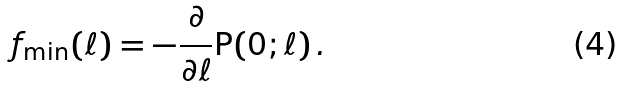<formula> <loc_0><loc_0><loc_500><loc_500>f _ { \min } ( \ell ) = - \frac { \partial } { \partial \ell } \text {P} ( 0 ; \ell ) \, .</formula> 